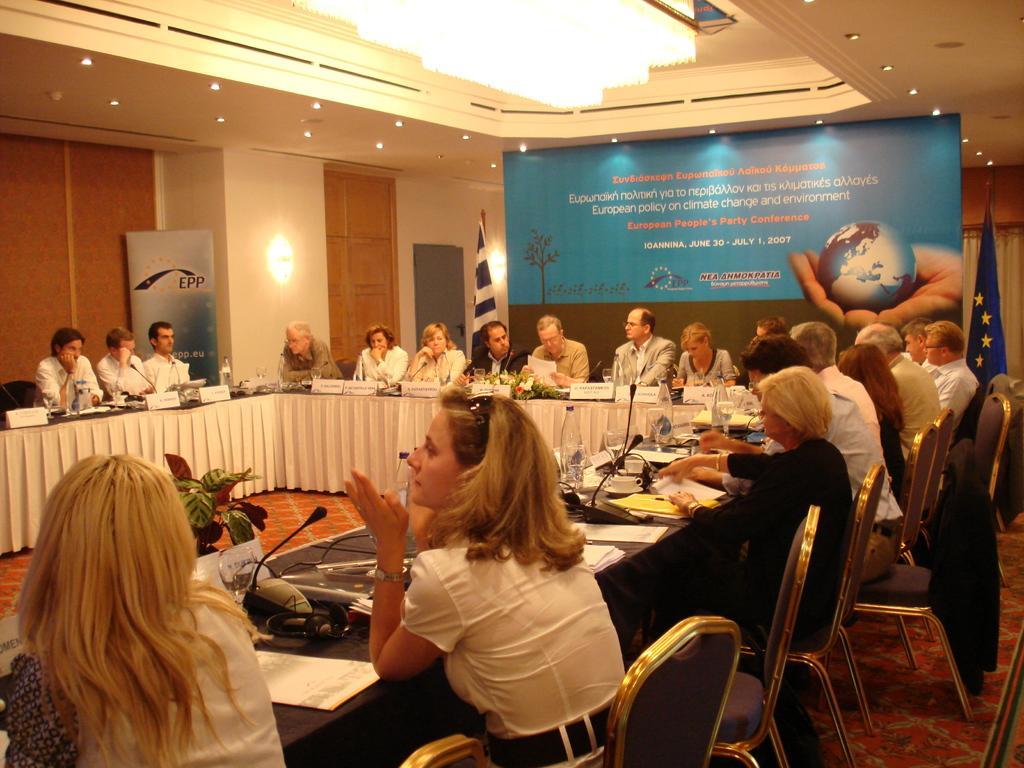Could you give a brief overview of what you see in this image? here in this picture we can see the conference room in which people are sitting on the chair with a table in front of them with a microphone,here on the table we can see different papers,water bottle,caps e. t. c, here on the wall we can see a banner with the text we can also see lights on the roof,here we can see a flag. 